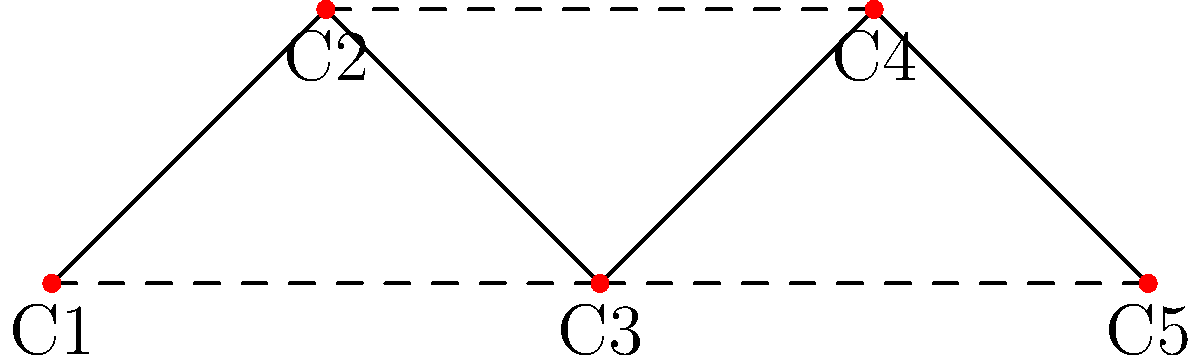Given a graph representing potential chicken breeding pairs, where nodes represent individual chickens and edges represent compatible breeding pairs, what is the maximum number of breeding pairs that can be selected to maximize genetic diversity without any chicken being used more than once? To solve this problem, we need to find the maximum matching in the given graph. Here's a step-by-step approach:

1. Identify the graph structure:
   - We have 5 nodes (C1, C2, C3, C4, C5) representing individual chickens.
   - Solid edges represent primary breeding pairs.
   - Dashed edges represent secondary breeding options.

2. List all possible breeding pairs:
   - (C1, C2), (C2, C3), (C3, C4), (C4, C5) [primary pairs]
   - (C1, C3), (C2, C4), (C3, C5) [secondary pairs]

3. Find the maximum matching:
   - Start with (C1, C2)
   - We can't use C2 or C1 again, so move to (C3, C4)
   - We can't use C3 or C4 again, so we're left with C5
   - No more pairs can be formed without reusing a chicken

4. Count the number of pairs in the maximum matching:
   - We have two pairs: (C1, C2) and (C3, C4)

Therefore, the maximum number of breeding pairs that can be selected to maximize genetic diversity without any chicken being used more than once is 2.
Answer: 2 pairs 